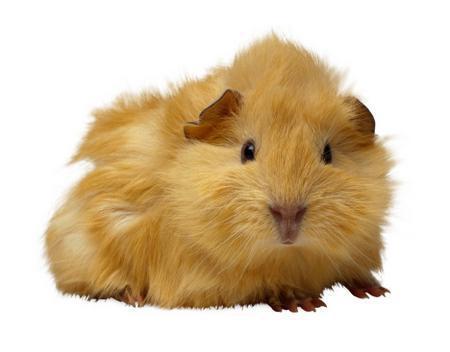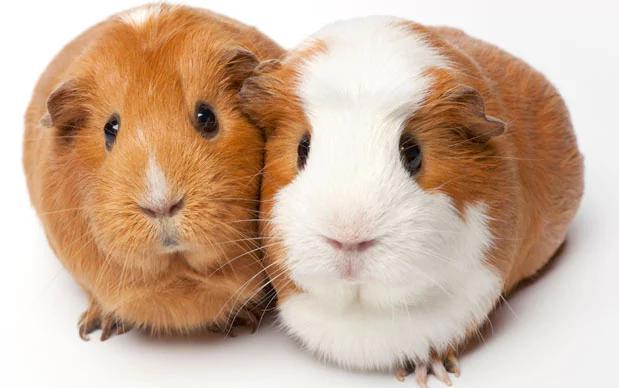The first image is the image on the left, the second image is the image on the right. For the images displayed, is the sentence "Each image contains one pair of side-by-side guinea pigs and includes at least one guinea pig that is not solid colored." factually correct? Answer yes or no. No. The first image is the image on the left, the second image is the image on the right. Evaluate the accuracy of this statement regarding the images: "Both images have two guinea pigs in them.". Is it true? Answer yes or no. No. 